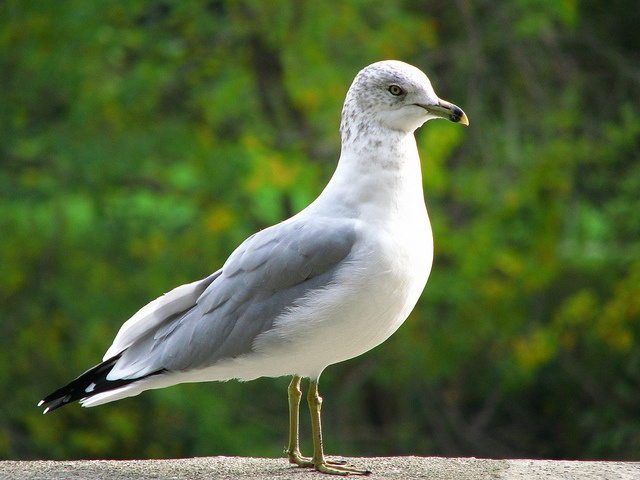Describe the objects in this image and their specific colors. I can see a bird in darkgreen, darkgray, lightgray, gray, and black tones in this image. 